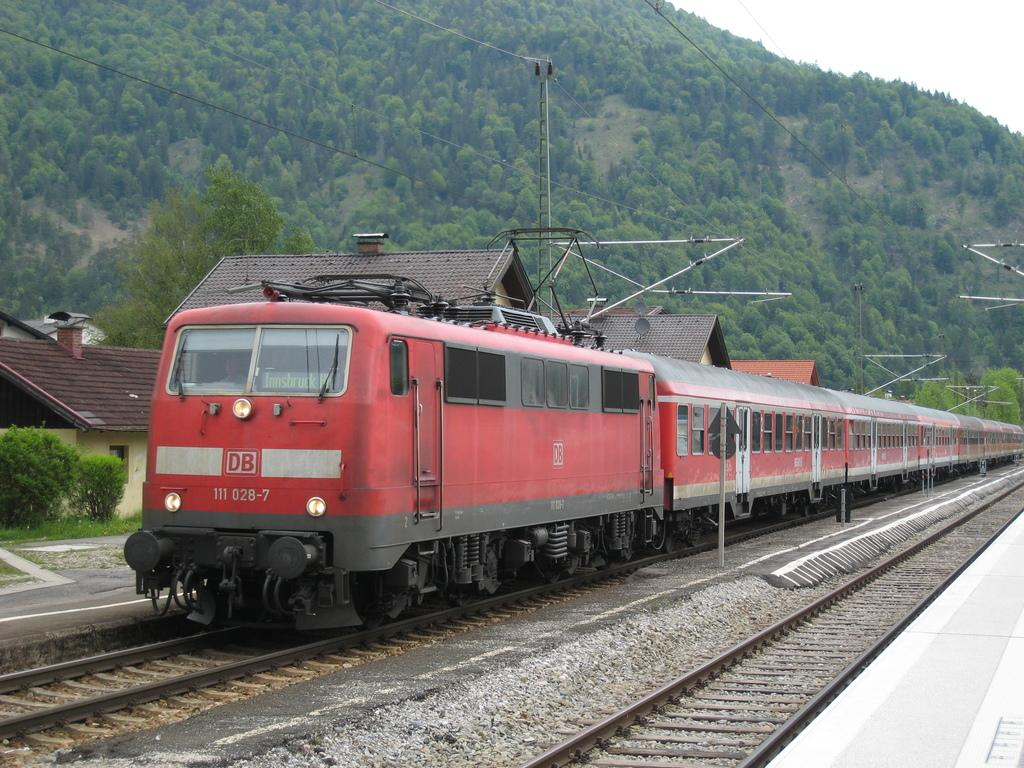<image>
Provide a brief description of the given image. A red train with DB on the front of it rides along the train tracks. 